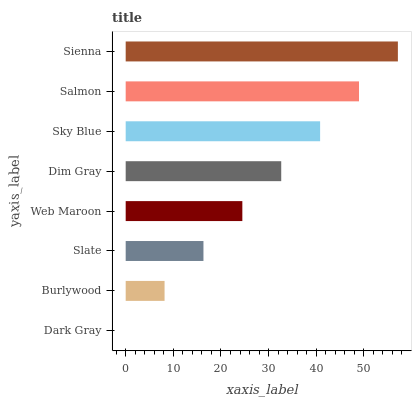Is Dark Gray the minimum?
Answer yes or no. Yes. Is Sienna the maximum?
Answer yes or no. Yes. Is Burlywood the minimum?
Answer yes or no. No. Is Burlywood the maximum?
Answer yes or no. No. Is Burlywood greater than Dark Gray?
Answer yes or no. Yes. Is Dark Gray less than Burlywood?
Answer yes or no. Yes. Is Dark Gray greater than Burlywood?
Answer yes or no. No. Is Burlywood less than Dark Gray?
Answer yes or no. No. Is Dim Gray the high median?
Answer yes or no. Yes. Is Web Maroon the low median?
Answer yes or no. Yes. Is Web Maroon the high median?
Answer yes or no. No. Is Dark Gray the low median?
Answer yes or no. No. 